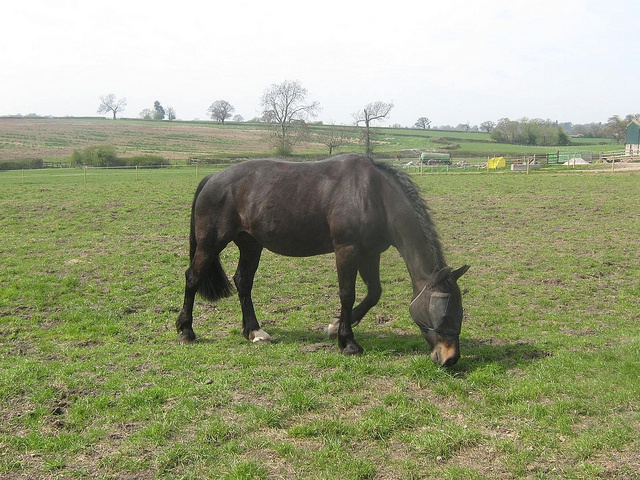Describe the objects in this image and their specific colors. I can see a horse in white, black, and gray tones in this image. 